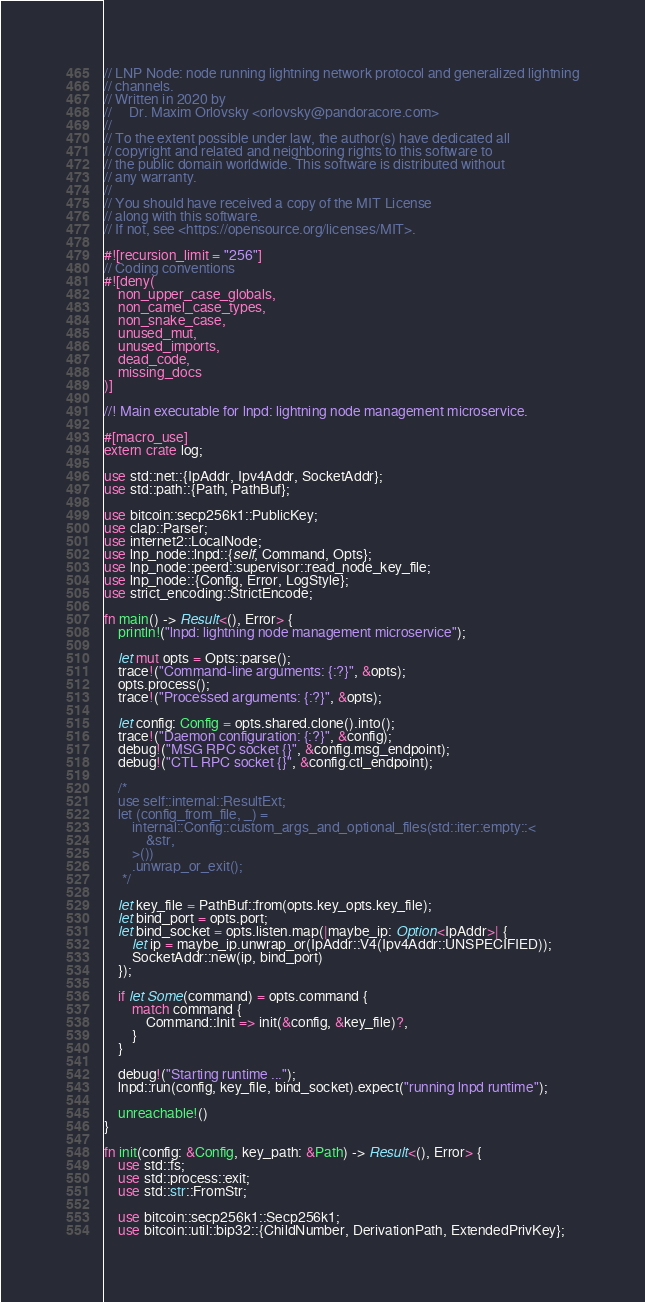Convert code to text. <code><loc_0><loc_0><loc_500><loc_500><_Rust_>// LNP Node: node running lightning network protocol and generalized lightning
// channels.
// Written in 2020 by
//     Dr. Maxim Orlovsky <orlovsky@pandoracore.com>
//
// To the extent possible under law, the author(s) have dedicated all
// copyright and related and neighboring rights to this software to
// the public domain worldwide. This software is distributed without
// any warranty.
//
// You should have received a copy of the MIT License
// along with this software.
// If not, see <https://opensource.org/licenses/MIT>.

#![recursion_limit = "256"]
// Coding conventions
#![deny(
    non_upper_case_globals,
    non_camel_case_types,
    non_snake_case,
    unused_mut,
    unused_imports,
    dead_code,
    missing_docs
)]

//! Main executable for lnpd: lightning node management microservice.

#[macro_use]
extern crate log;

use std::net::{IpAddr, Ipv4Addr, SocketAddr};
use std::path::{Path, PathBuf};

use bitcoin::secp256k1::PublicKey;
use clap::Parser;
use internet2::LocalNode;
use lnp_node::lnpd::{self, Command, Opts};
use lnp_node::peerd::supervisor::read_node_key_file;
use lnp_node::{Config, Error, LogStyle};
use strict_encoding::StrictEncode;

fn main() -> Result<(), Error> {
    println!("lnpd: lightning node management microservice");

    let mut opts = Opts::parse();
    trace!("Command-line arguments: {:?}", &opts);
    opts.process();
    trace!("Processed arguments: {:?}", &opts);

    let config: Config = opts.shared.clone().into();
    trace!("Daemon configuration: {:?}", &config);
    debug!("MSG RPC socket {}", &config.msg_endpoint);
    debug!("CTL RPC socket {}", &config.ctl_endpoint);

    /*
    use self::internal::ResultExt;
    let (config_from_file, _) =
        internal::Config::custom_args_and_optional_files(std::iter::empty::<
            &str,
        >())
        .unwrap_or_exit();
     */

    let key_file = PathBuf::from(opts.key_opts.key_file);
    let bind_port = opts.port;
    let bind_socket = opts.listen.map(|maybe_ip: Option<IpAddr>| {
        let ip = maybe_ip.unwrap_or(IpAddr::V4(Ipv4Addr::UNSPECIFIED));
        SocketAddr::new(ip, bind_port)
    });

    if let Some(command) = opts.command {
        match command {
            Command::Init => init(&config, &key_file)?,
        }
    }

    debug!("Starting runtime ...");
    lnpd::run(config, key_file, bind_socket).expect("running lnpd runtime");

    unreachable!()
}

fn init(config: &Config, key_path: &Path) -> Result<(), Error> {
    use std::fs;
    use std::process::exit;
    use std::str::FromStr;

    use bitcoin::secp256k1::Secp256k1;
    use bitcoin::util::bip32::{ChildNumber, DerivationPath, ExtendedPrivKey};</code> 